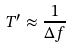Convert formula to latex. <formula><loc_0><loc_0><loc_500><loc_500>T ^ { \prime } \approx \frac { 1 } { \Delta f }</formula> 